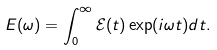Convert formula to latex. <formula><loc_0><loc_0><loc_500><loc_500>E ( \omega ) = \int _ { 0 } ^ { \infty } \mathcal { E } ( t ) \exp ( i \omega t ) d t .</formula> 